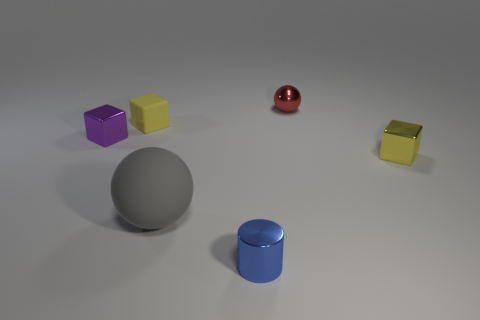Subtract all small purple blocks. How many blocks are left? 2 Subtract all red balls. How many balls are left? 1 Subtract all cylinders. How many objects are left? 5 Subtract all cyan cylinders. How many gray balls are left? 1 Subtract all gray cubes. Subtract all green balls. How many cubes are left? 3 Subtract all big yellow metallic blocks. Subtract all tiny yellow metallic objects. How many objects are left? 5 Add 3 red objects. How many red objects are left? 4 Add 5 green shiny objects. How many green shiny objects exist? 5 Add 4 purple cubes. How many objects exist? 10 Subtract 1 purple cubes. How many objects are left? 5 